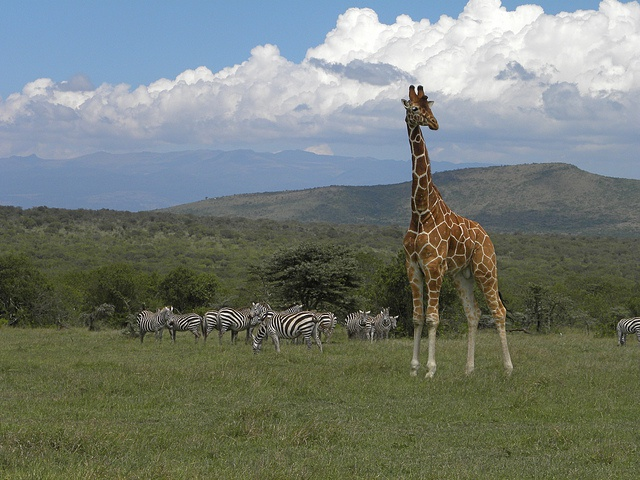Describe the objects in this image and their specific colors. I can see giraffe in darkgray, olive, maroon, gray, and black tones, zebra in darkgray, gray, black, and lightgray tones, zebra in darkgray, black, gray, and darkgreen tones, zebra in darkgray, gray, black, and darkgreen tones, and zebra in darkgray, gray, black, and darkgreen tones in this image. 